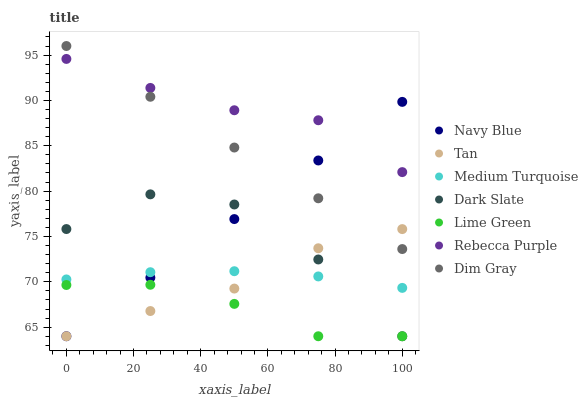Does Lime Green have the minimum area under the curve?
Answer yes or no. Yes. Does Rebecca Purple have the maximum area under the curve?
Answer yes or no. Yes. Does Navy Blue have the minimum area under the curve?
Answer yes or no. No. Does Navy Blue have the maximum area under the curve?
Answer yes or no. No. Is Navy Blue the smoothest?
Answer yes or no. Yes. Is Dark Slate the roughest?
Answer yes or no. Yes. Is Dark Slate the smoothest?
Answer yes or no. No. Is Navy Blue the roughest?
Answer yes or no. No. Does Navy Blue have the lowest value?
Answer yes or no. Yes. Does Rebecca Purple have the lowest value?
Answer yes or no. No. Does Dim Gray have the highest value?
Answer yes or no. Yes. Does Navy Blue have the highest value?
Answer yes or no. No. Is Medium Turquoise less than Rebecca Purple?
Answer yes or no. Yes. Is Rebecca Purple greater than Dark Slate?
Answer yes or no. Yes. Does Navy Blue intersect Dim Gray?
Answer yes or no. Yes. Is Navy Blue less than Dim Gray?
Answer yes or no. No. Is Navy Blue greater than Dim Gray?
Answer yes or no. No. Does Medium Turquoise intersect Rebecca Purple?
Answer yes or no. No. 